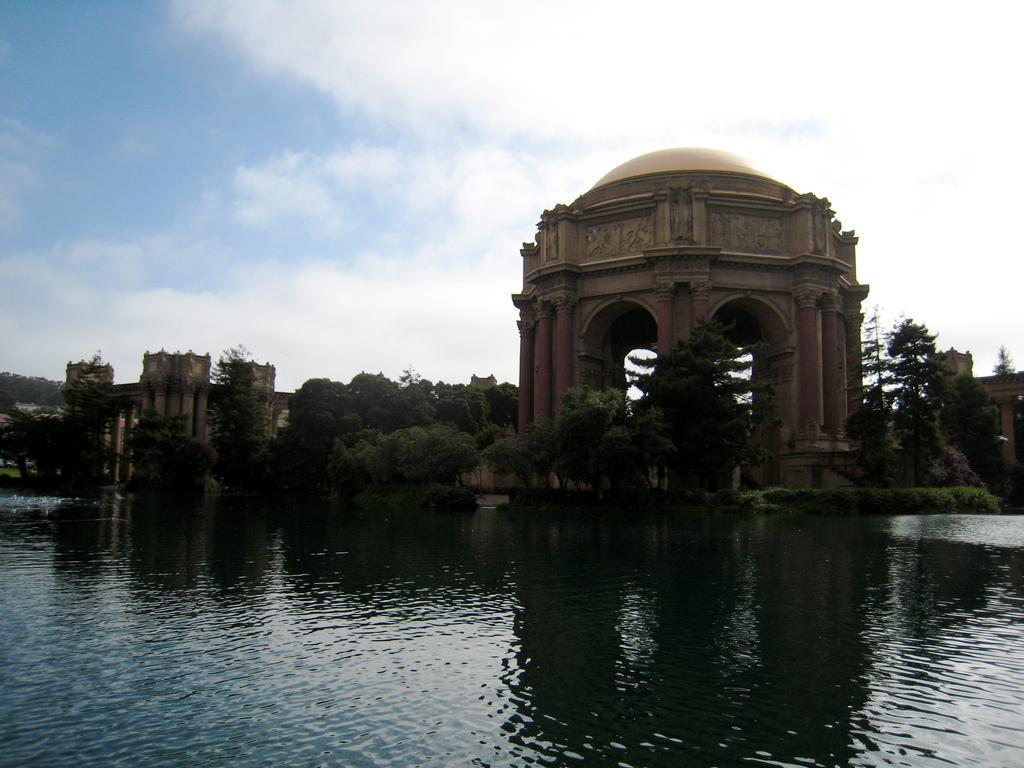Describe this image in one or two sentences. In this picture we can see water, plants, trees, and forests. In the background there is sky with clouds. 